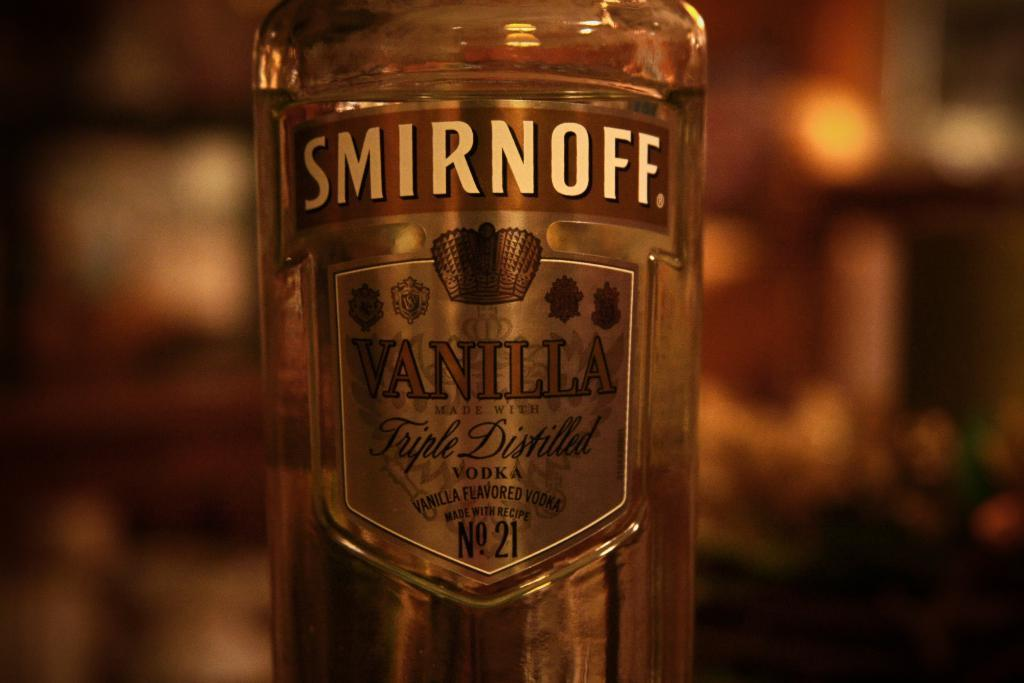<image>
Write a terse but informative summary of the picture. a full bottle of smirnoff vanilla triple distilled vodka 